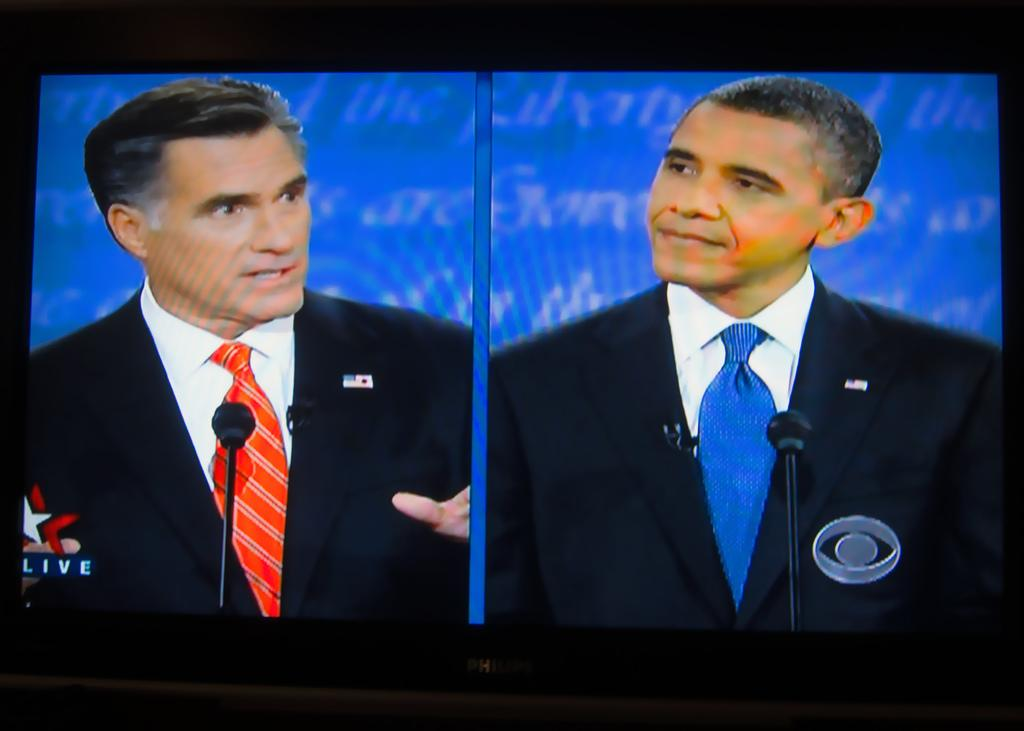What electronic device is present in the image? There is a television in the image. What is being shown on the television? The television is displaying something. Who is speaking in the image? There are men speaking in the image. How are the men amplifying their voices? The men are using microphones. Can you see a whip being used by the men in the image? No, there is no whip present in the image. How can someone join the conversation happening in the image? The question is not relevant to the image, as it does not provide information on how to join the conversation or if it is even possible. --- Facts: 1. There is a car in the image. 2. The car is parked on the street. 3. There are trees on the side of the street. 4. The sky is visible in the image. Absurd Topics: parrot, dance, ocean Conversation: What type of vehicle is present in the image? There is a car in the image. Where is the car located? The car is parked on the street. What type of vegetation is present on the side of the street? There are trees on the side of the street. What is visible in the background of the image? The sky is visible in the image. Reasoning: Let's think step by step in order to produce the conversation. We start by identifying the main subject in the image, which is the car. Then, we describe the location of the car, which is parked on the street. Next, we identify the type of vegetation present on the side of the street, which are trees. Finally, we mention the background of the image, which is the sky. Absurd Question/Answer: Can you see a parrot perched on the car in the image? No, there is no parrot present in the image. Is there a dance performance happening in the image? No, there is no dance performance present in the image. 